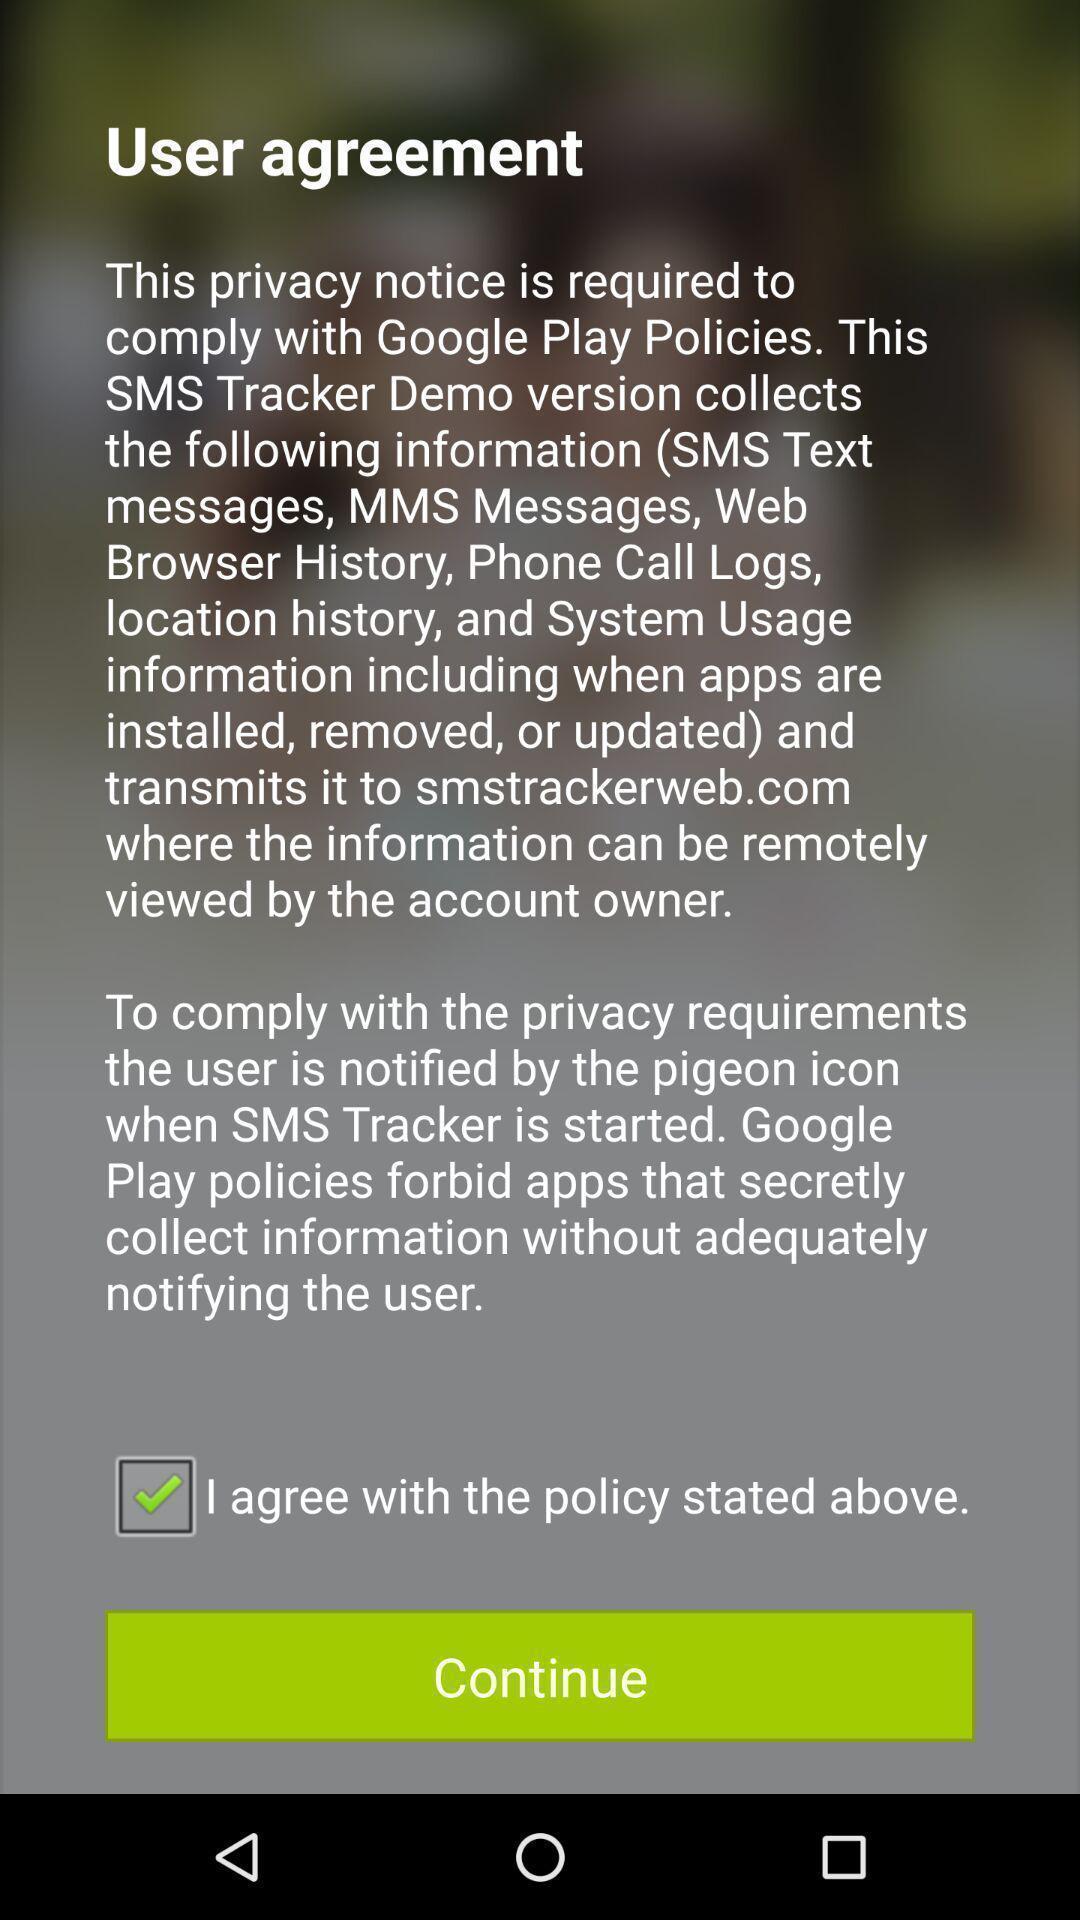What is the overall content of this screenshot? Pop-up displaying continue button in app. 